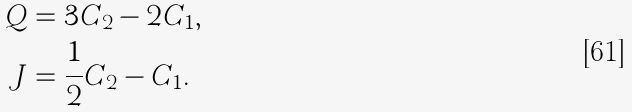<formula> <loc_0><loc_0><loc_500><loc_500>Q & = 3 C _ { 2 } - 2 C _ { 1 } , \\ J & = \frac { 1 } { 2 } C _ { 2 } - C _ { 1 } .</formula> 